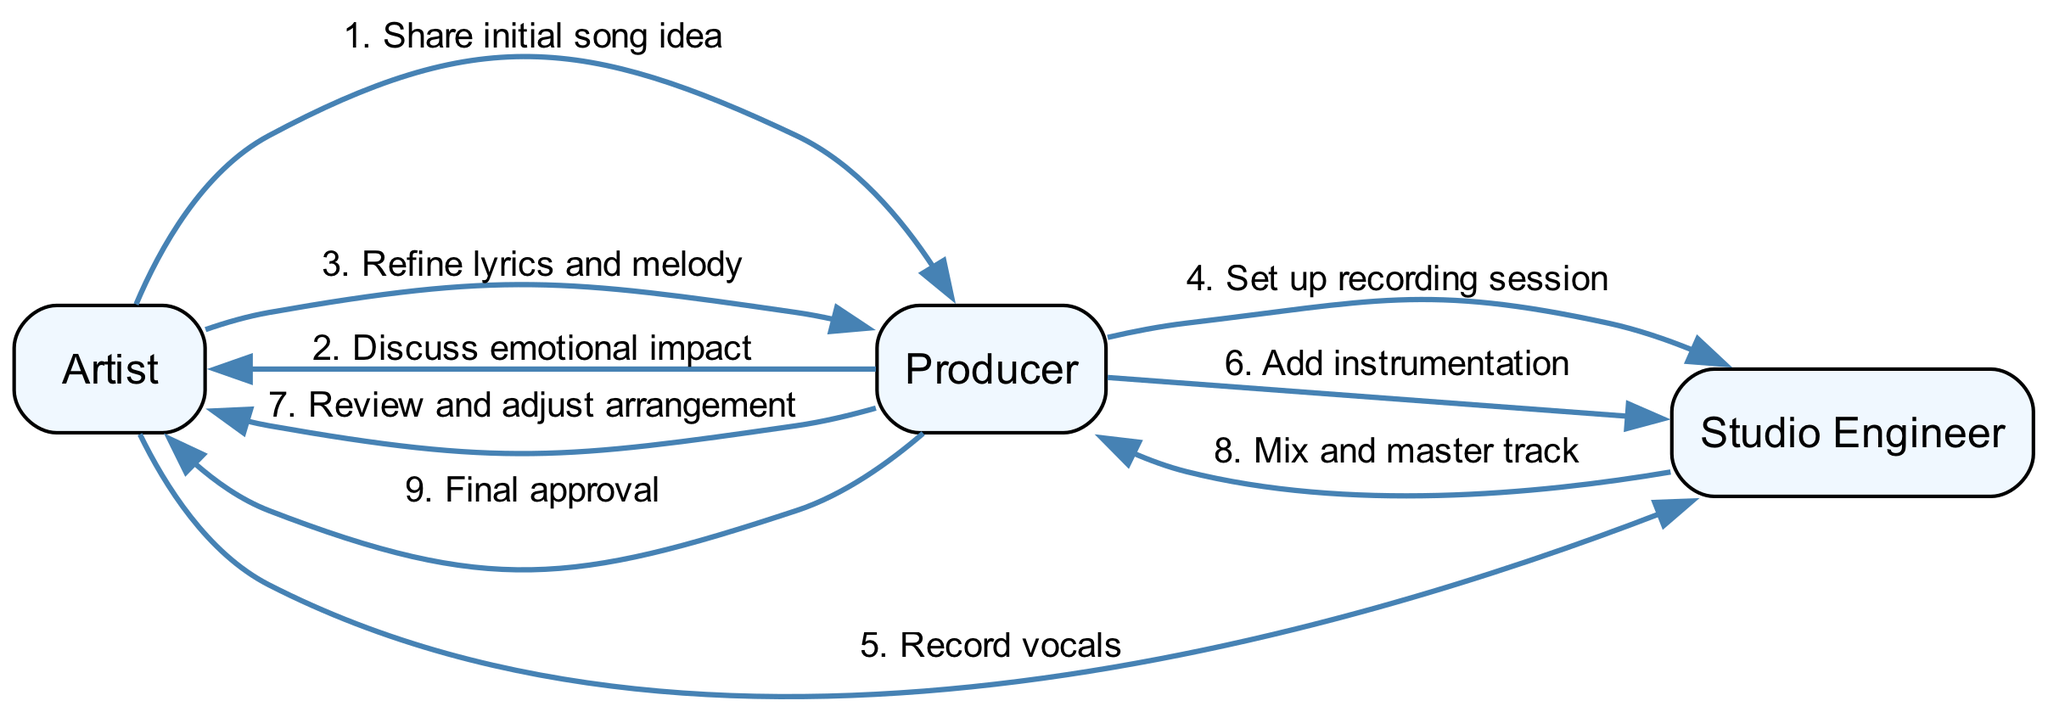What is the first message in the sequence? The first message in the sequence is sent from the Artist to the Producer, where the Artist shares the initial song idea.
Answer: Share initial song idea How many actors are involved in the process? There are three actors involved in the process: Artist, Producer, and Studio Engineer.
Answer: 3 Who does the Producer communicate with after receiving the song idea from the Artist? After receiving the song idea, the Producer communicates with the Artist to discuss the emotional impact of the song.
Answer: Artist Which message is sent to the Studio Engineer first? The first message sent to the Studio Engineer is from the Producer to set up the recording session.
Answer: Set up recording session What is the last step in the sequence? The last step in the sequence involves the Producer sending a message to the Artist for final approval of the track.
Answer: Final approval After the Artist records vocals, what does the Producer instruct the Studio Engineer to do? After the Artist records vocals, the Producer instructs the Studio Engineer to add instrumentation to the track.
Answer: Add instrumentation How many messages are exchanged between the Artist and Producer? There are four messages exchanged between the Artist and Producer throughout the sequence of actions.
Answer: 4 What role does the Studio Engineer have in the mixing process? The Studio Engineer is responsible for mixing and mastering the track after recording and instrumentation.
Answer: Mix and master track What is the emotional focus of the discussion between the Artist and Producer? The emotional focus of the discussion is on the emotional impact of the song, as highlighted in their communication.
Answer: Discuss emotional impact 